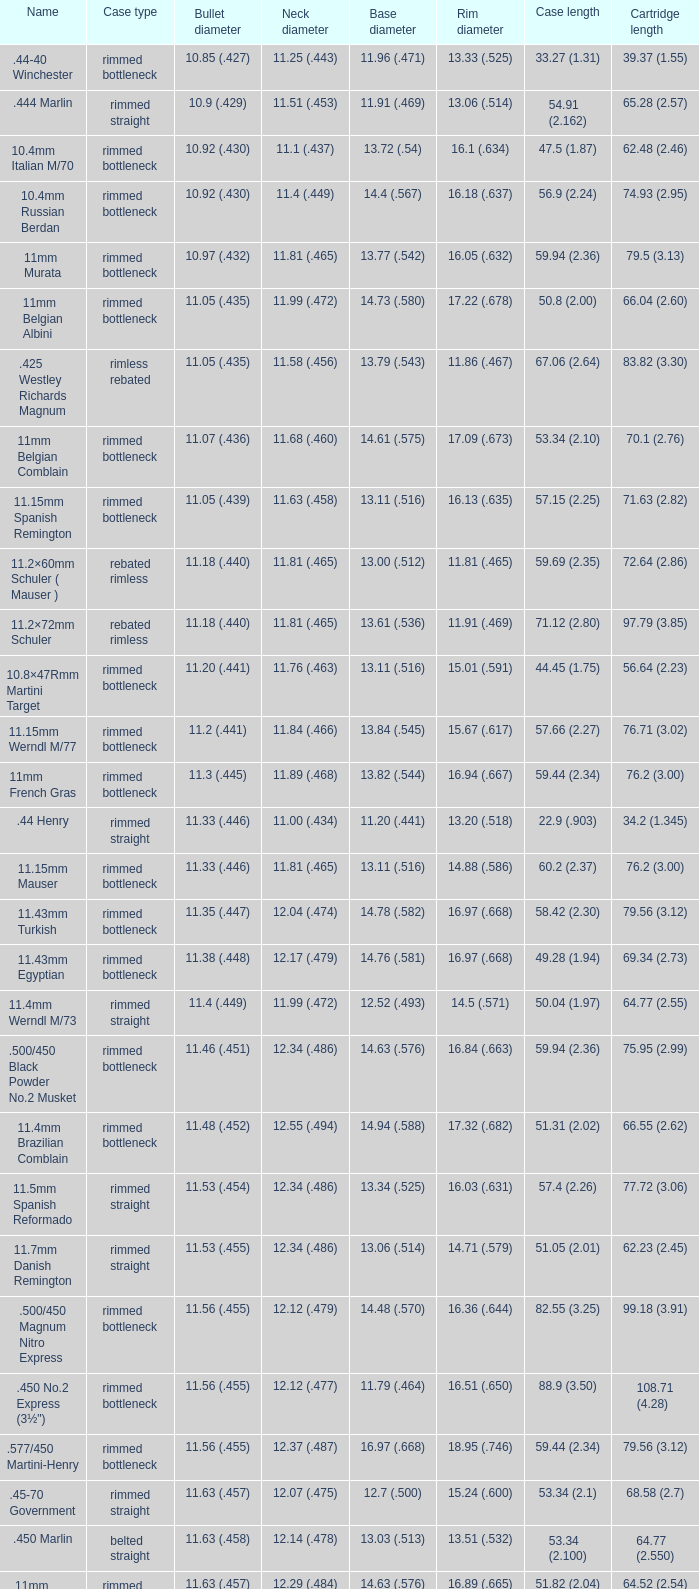Which Case type has a Cartridge length of 64.77 (2.550)? Belted straight. 